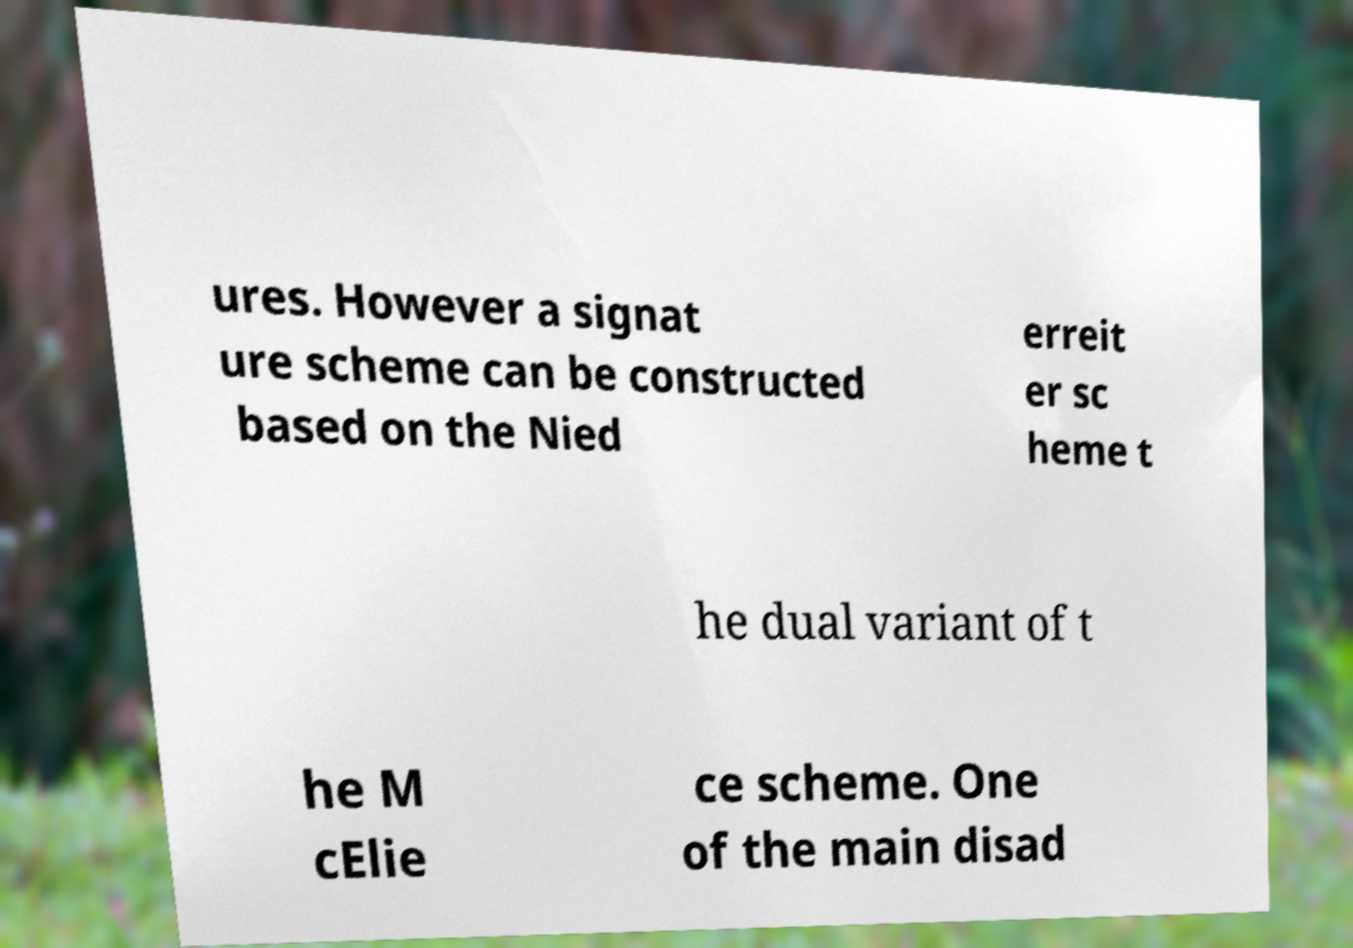I need the written content from this picture converted into text. Can you do that? ures. However a signat ure scheme can be constructed based on the Nied erreit er sc heme t he dual variant of t he M cElie ce scheme. One of the main disad 